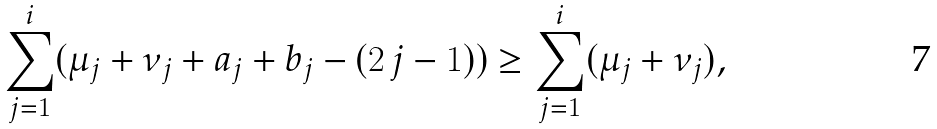Convert formula to latex. <formula><loc_0><loc_0><loc_500><loc_500>\sum _ { j = 1 } ^ { i } ( \mu _ { j } + \nu _ { j } + a _ { j } + b _ { j } - ( 2 \, j - 1 ) ) \geq \sum _ { j = 1 } ^ { i } ( \mu _ { j } + \nu _ { j } ) ,</formula> 